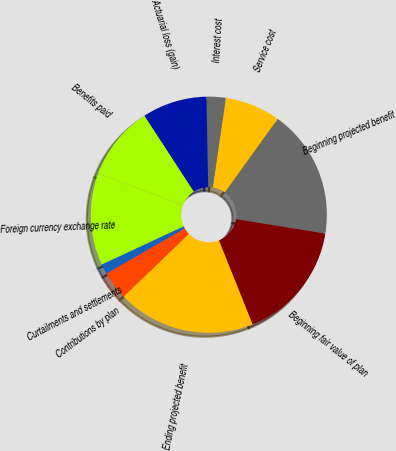Convert chart to OTSL. <chart><loc_0><loc_0><loc_500><loc_500><pie_chart><fcel>Beginning projected benefit<fcel>Service cost<fcel>Interest cost<fcel>Actuarial loss (gain)<fcel>Benefits paid<fcel>Foreign currency exchange rate<fcel>Curtailments and settlements<fcel>Contributions by plan<fcel>Ending projected benefit<fcel>Beginning fair value of plan<nl><fcel>17.63%<fcel>7.62%<fcel>2.62%<fcel>8.87%<fcel>10.13%<fcel>12.63%<fcel>1.36%<fcel>3.87%<fcel>18.89%<fcel>16.38%<nl></chart> 